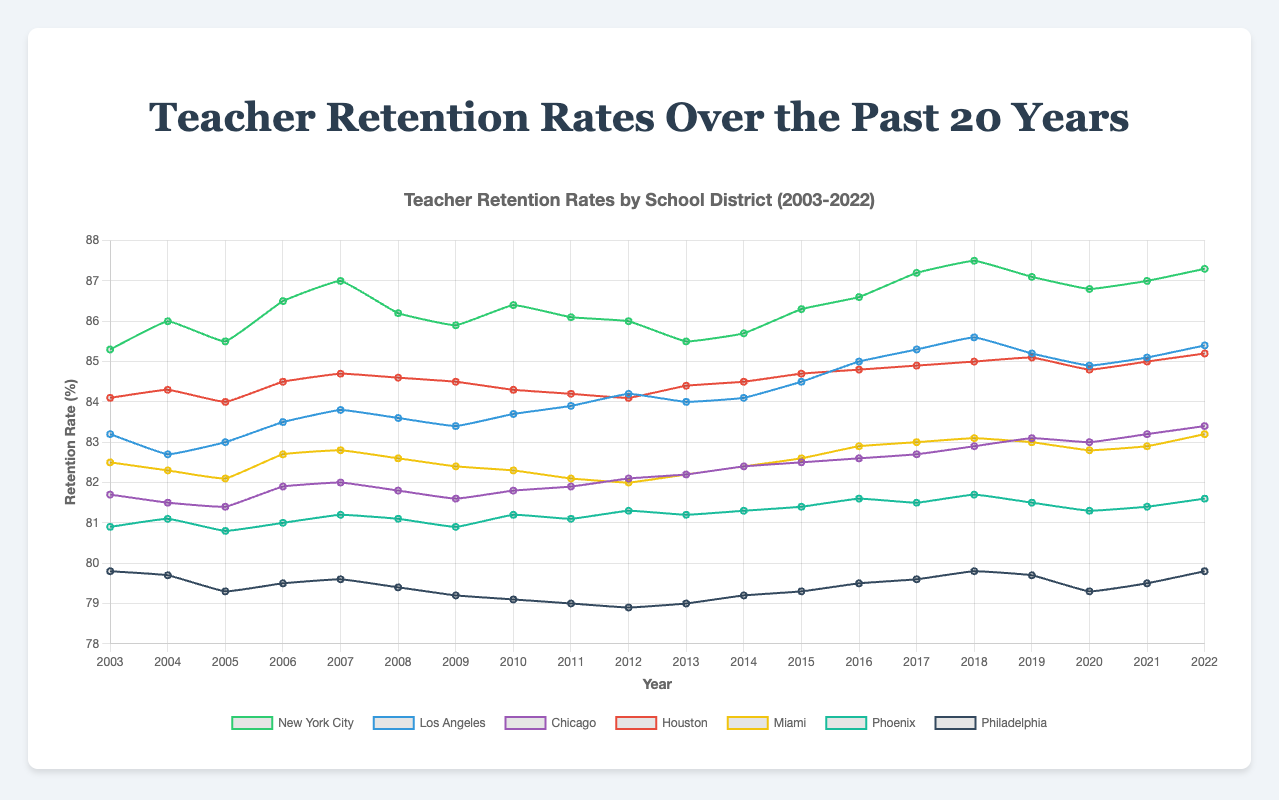What's the trend in teacher retention rates for New York City over the past 20 years? To determine the trend, observe the line representing New York City. Starting at 85.3% in 2003, the retention rate shows an overall upward trend, reaching 87.3% in 2022.
Answer: Upward trend Which district had the lowest retention rate in 2022? Compare the retention rates of all the districts for the year 2022. Philadelphia's rate was 79.8%, which is the lowest among all the districts.
Answer: Philadelphia How does the retention rate of Los Angeles in 2022 compare to that of 2003? The retention rate for Los Angeles was 83.2% in 2003 and increased to 85.4% in 2022. By subtracting 83.2% from 85.4%, it shows an increase of 2.2%.
Answer: Increased by 2.2% Which district shows the most consistent retention rate over the years? The district with minimal fluctuation in its retention rate over the years appears to be Phoenix, as its trend line remains relatively stable around the 81% mark without much variance.
Answer: Phoenix Compare the highest and lowest retention rates in 2016. In 2016, the highest retention rate was in New York City at 86.6%, and the lowest was in Philadelphia at 79.5%.
Answer: New York City: 86.6%, Philadelphia: 79.5% What's the average retention rate for Chicago over the 20 years? Sum the retention rates for Chicago over the 20 years and divide by 20. (81.7 + 81.5 + 81.4 + 81.9 + 82.0 + 81.8 + 81.6 + 81.8 + 81.9 + 82.1 + 82.2 + 82.4 + 82.5 + 82.6 + 82.7 + 82.9 + 83.1 + 83.0 + 83.2 + 83.4) = 1655.7 / 20 = 82.785%
Answer: 82.8% (rounded) In which year did Miami experience the highest retention rate? Look at the data points for Miami over the 20 years. The highest retention rate for Miami was 83.2% in 2022.
Answer: 2022 How does the retention rate trend for Houston compare to that of Phoenix? Houston's retention rate shows a slight overall upward trend from 84.1% to 85.2%, while Phoenix maintains a relatively stable rate around 81%. Houston's trend is upward, while Phoenix's remains consistent.
Answer: Houston: upward, Phoenix: consistent 